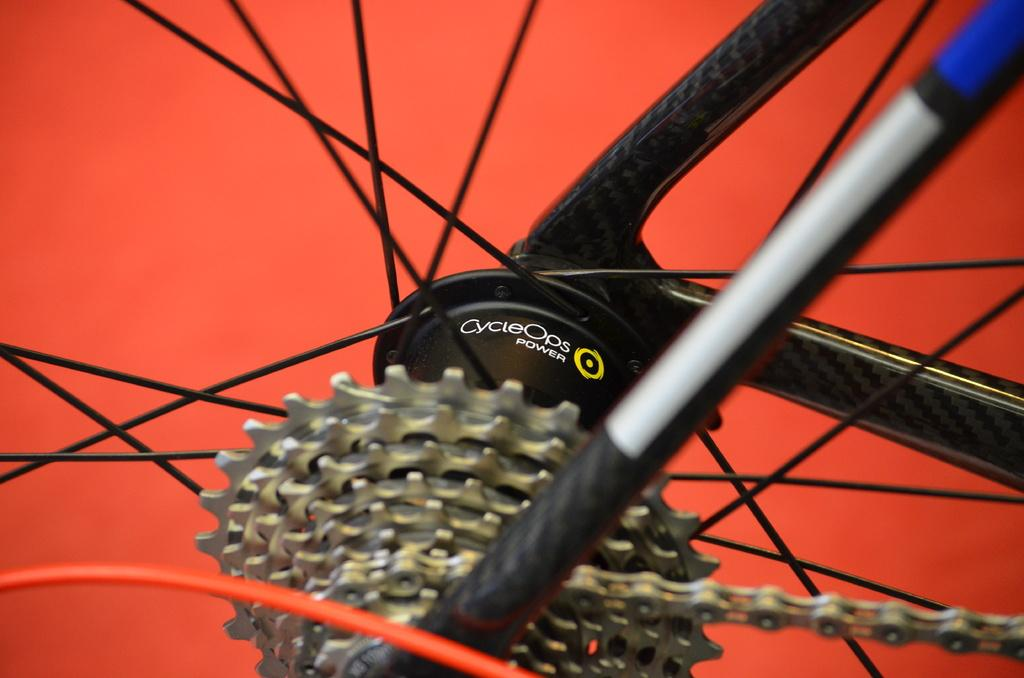What type of object is depicted in the image? The image contains spokes, a chain, and a hub, which suggests it is a wheel or similar object. Can you describe the chain in the image? Yes, there is a chain in the image. What is the color of the background in the image? The background of the image is red. What type of scarecrow is standing in the aftermath of the storm in the image? There is no scarecrow or storm present in the image; it features a wheel-like object with spokes, a chain, and a hub against a red background. What medical advice does the doctor provide in the image? There is no doctor or medical advice present in the image. 